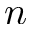Convert formula to latex. <formula><loc_0><loc_0><loc_500><loc_500>n</formula> 